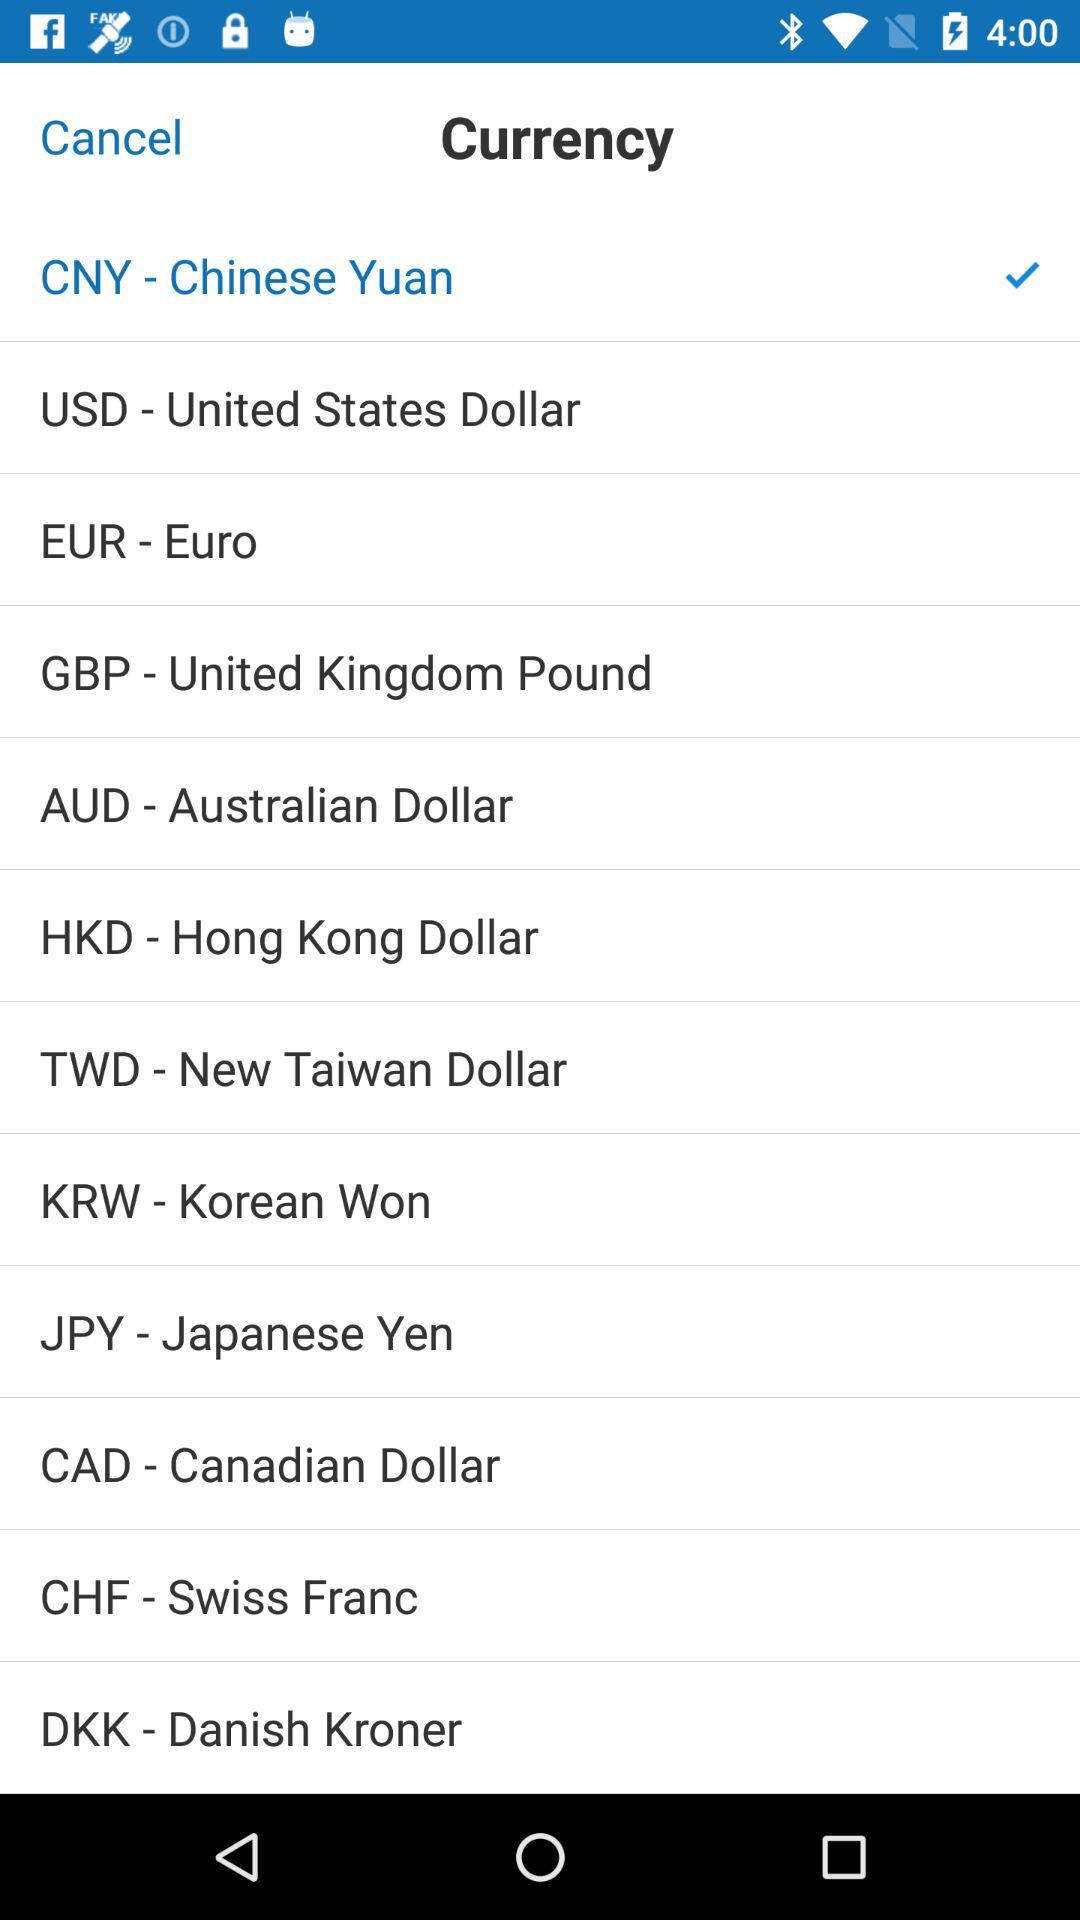What's the selected currency? The selected currency is the Chinese Yuan (CNY). 